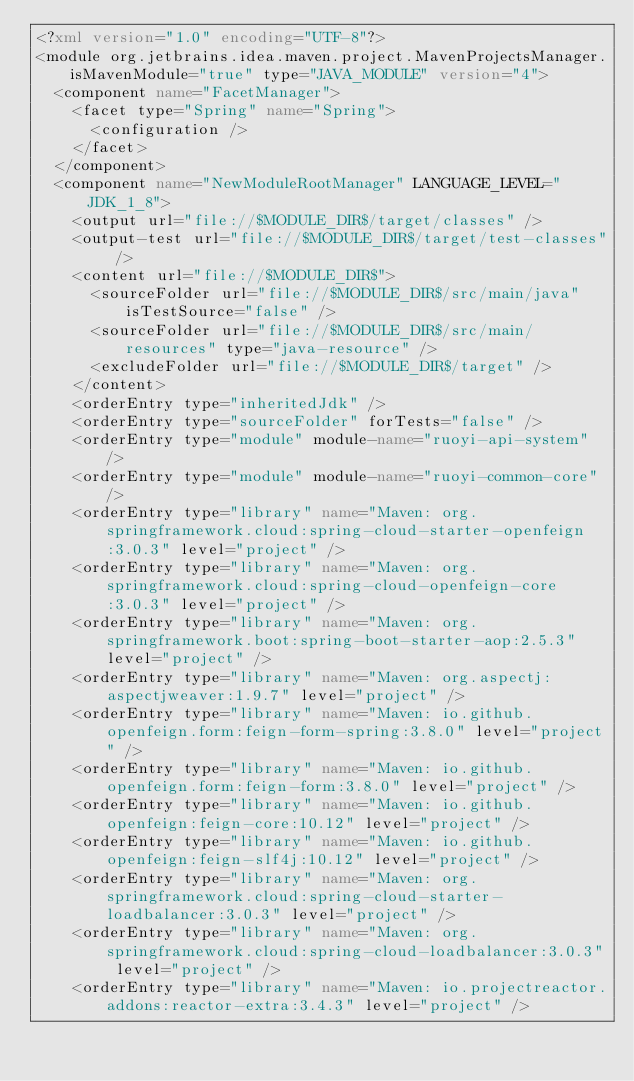<code> <loc_0><loc_0><loc_500><loc_500><_XML_><?xml version="1.0" encoding="UTF-8"?>
<module org.jetbrains.idea.maven.project.MavenProjectsManager.isMavenModule="true" type="JAVA_MODULE" version="4">
  <component name="FacetManager">
    <facet type="Spring" name="Spring">
      <configuration />
    </facet>
  </component>
  <component name="NewModuleRootManager" LANGUAGE_LEVEL="JDK_1_8">
    <output url="file://$MODULE_DIR$/target/classes" />
    <output-test url="file://$MODULE_DIR$/target/test-classes" />
    <content url="file://$MODULE_DIR$">
      <sourceFolder url="file://$MODULE_DIR$/src/main/java" isTestSource="false" />
      <sourceFolder url="file://$MODULE_DIR$/src/main/resources" type="java-resource" />
      <excludeFolder url="file://$MODULE_DIR$/target" />
    </content>
    <orderEntry type="inheritedJdk" />
    <orderEntry type="sourceFolder" forTests="false" />
    <orderEntry type="module" module-name="ruoyi-api-system" />
    <orderEntry type="module" module-name="ruoyi-common-core" />
    <orderEntry type="library" name="Maven: org.springframework.cloud:spring-cloud-starter-openfeign:3.0.3" level="project" />
    <orderEntry type="library" name="Maven: org.springframework.cloud:spring-cloud-openfeign-core:3.0.3" level="project" />
    <orderEntry type="library" name="Maven: org.springframework.boot:spring-boot-starter-aop:2.5.3" level="project" />
    <orderEntry type="library" name="Maven: org.aspectj:aspectjweaver:1.9.7" level="project" />
    <orderEntry type="library" name="Maven: io.github.openfeign.form:feign-form-spring:3.8.0" level="project" />
    <orderEntry type="library" name="Maven: io.github.openfeign.form:feign-form:3.8.0" level="project" />
    <orderEntry type="library" name="Maven: io.github.openfeign:feign-core:10.12" level="project" />
    <orderEntry type="library" name="Maven: io.github.openfeign:feign-slf4j:10.12" level="project" />
    <orderEntry type="library" name="Maven: org.springframework.cloud:spring-cloud-starter-loadbalancer:3.0.3" level="project" />
    <orderEntry type="library" name="Maven: org.springframework.cloud:spring-cloud-loadbalancer:3.0.3" level="project" />
    <orderEntry type="library" name="Maven: io.projectreactor.addons:reactor-extra:3.4.3" level="project" /></code> 